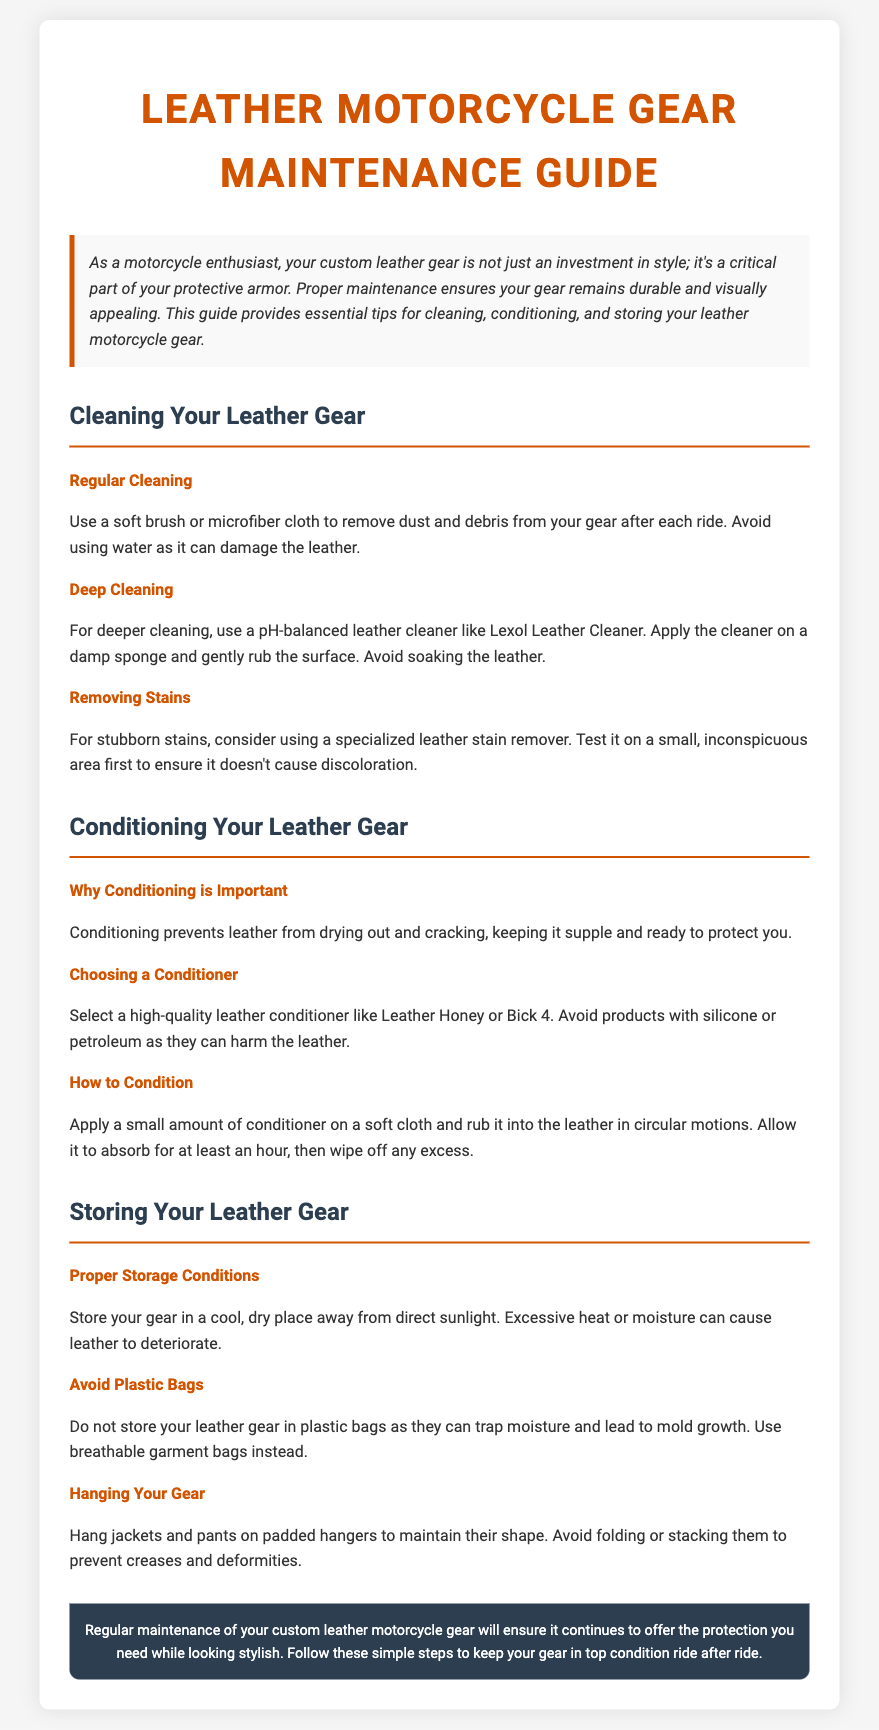What is the title of the guide? The title of the guide is stated at the top of the document.
Answer: Leather Motorcycle Gear Maintenance Guide What should you use to remove dust after each ride? The document specifies the tool for dust removal in the cleaning section.
Answer: Soft brush or microfiber cloth What is a recommended leather cleaner? The document mentions a specific product suitable for deeper cleaning.
Answer: Lexol Leather Cleaner Why is conditioning important? The document provides the reason for conditioning in the conditioning section.
Answer: Prevents leather from drying out and cracking What should you not store leather gear in? The document warns against a specific storage method in the storing section.
Answer: Plastic bags What type of hanger is suggested for jackets? The document provides a recommendation for how to hang jackets properly in the storage section.
Answer: Padded hangers What should be avoided in conditioners? The document specifies harmful components to avoid in the conditioner selection.
Answer: Silicone or petroleum What is recommended to avoid when storing gear? The document highlights an action to avoid in the proper storage conditions.
Answer: Folding or stacking 